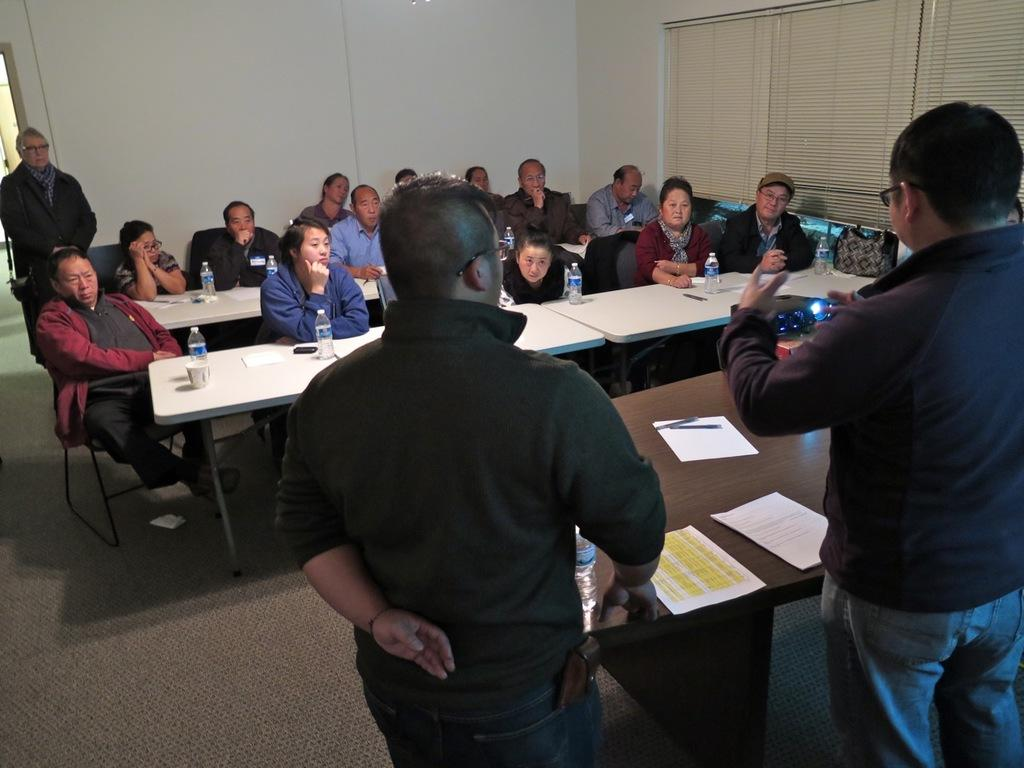What are the people in the image doing? There is a group of people sitting on chairs in the image. What objects are in front of the chairs? There are tables in front of the chairs. What can be seen on the tables? There is a cup, a bottle, a mobile, and papers on the tables. Can you describe the window visible in the image? There is a window visible in the image, but its characteristics are not mentioned in the facts. What else can be observed about the people in the image? Two people are standing in the image. What type of flowers are on the table with the cup? There are no flowers mentioned or visible in the image. 